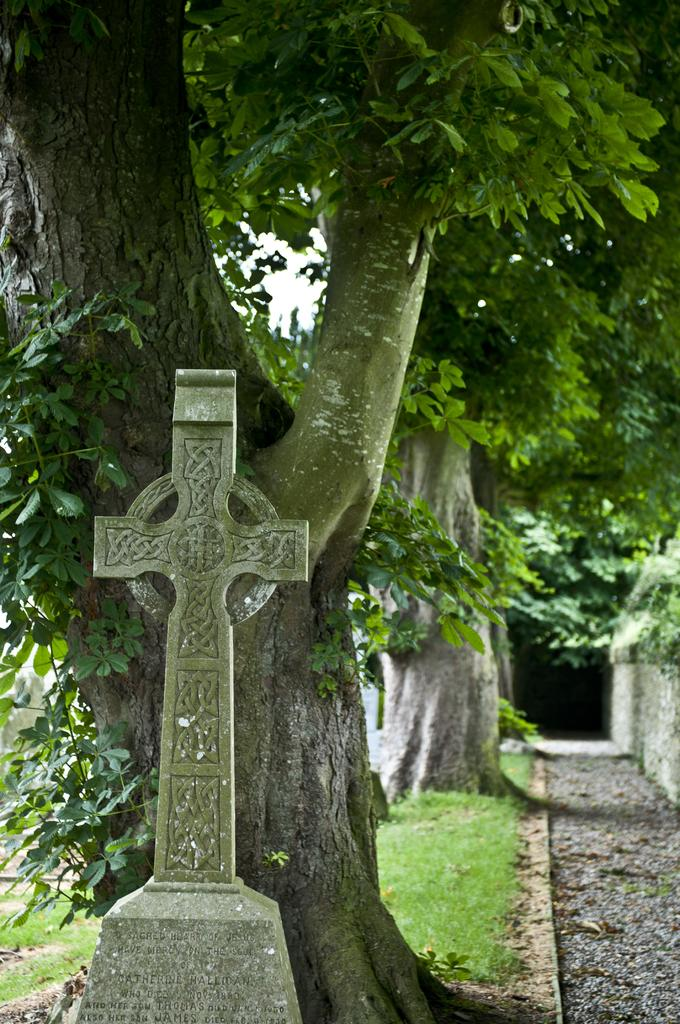What is the main subject of the image? There is a Jesus cross memorial statue in the image. Where is the statue located in relation to the image? The statue is located at the bottom of the image. What can be seen in the background of the image? There are trees in the background of the image. What type of dolls are hanging from the statue in the image? There are no dolls present in the image; it features a Jesus cross memorial statue. What material is the statue made of, and is it leather or metal? The material of the statue is not mentioned in the facts, and there is no indication of leather or metal being involved. 